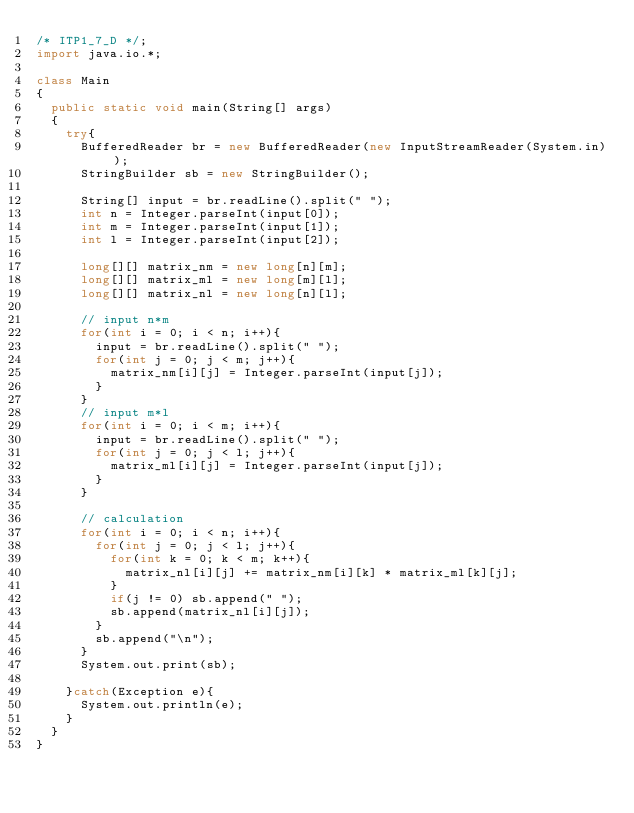Convert code to text. <code><loc_0><loc_0><loc_500><loc_500><_Java_>/* ITP1_7_D */;
import java.io.*;

class Main
{
  public static void main(String[] args)
  {
    try{
      BufferedReader br = new BufferedReader(new InputStreamReader(System.in));
      StringBuilder sb = new StringBuilder();

      String[] input = br.readLine().split(" ");
      int n = Integer.parseInt(input[0]);
      int m = Integer.parseInt(input[1]);
      int l = Integer.parseInt(input[2]);

      long[][] matrix_nm = new long[n][m];
      long[][] matrix_ml = new long[m][l];
      long[][] matrix_nl = new long[n][l];

      // input n*m
      for(int i = 0; i < n; i++){
        input = br.readLine().split(" ");
        for(int j = 0; j < m; j++){
          matrix_nm[i][j] = Integer.parseInt(input[j]);
        }
      }
      // input m*l
      for(int i = 0; i < m; i++){
        input = br.readLine().split(" ");
        for(int j = 0; j < l; j++){
          matrix_ml[i][j] = Integer.parseInt(input[j]);
        }
      }

      // calculation
      for(int i = 0; i < n; i++){
        for(int j = 0; j < l; j++){
          for(int k = 0; k < m; k++){
            matrix_nl[i][j] += matrix_nm[i][k] * matrix_ml[k][j];
          }
          if(j != 0) sb.append(" ");
          sb.append(matrix_nl[i][j]);
        }
        sb.append("\n");
      }
      System.out.print(sb);

    }catch(Exception e){
      System.out.println(e);
    }
  }
}</code> 